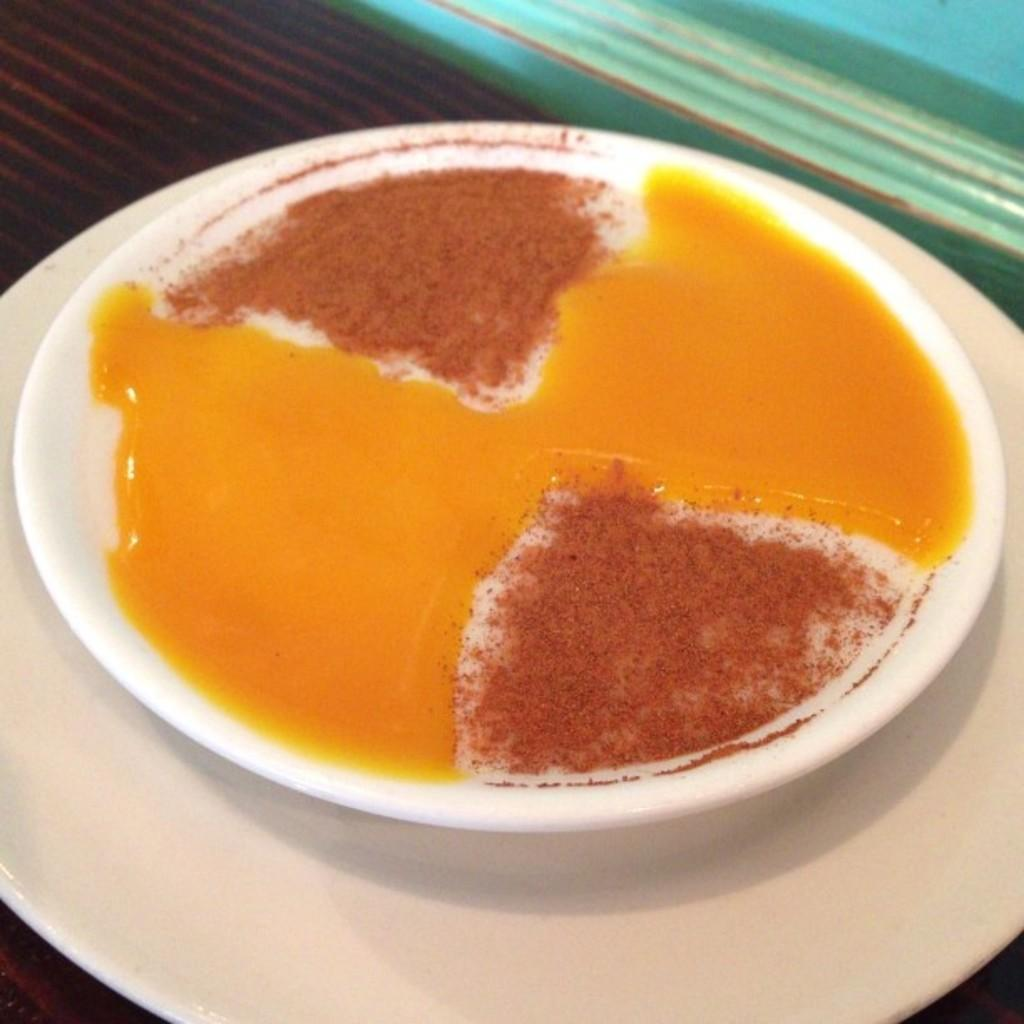What is the arrangement of the plates in the image? There is a plate on another plate in the image. What can be found on the top plate? There is a food item on the top plate. On what surface are the plates placed? The plates are on a wooden surface. How many men can be seen walking through the town in the image? There are no men or town present in the image; it features plates with a food item on a wooden surface. What type of box is visible in the image? There is no box present in the image; it features plates with a food item on a wooden surface. 